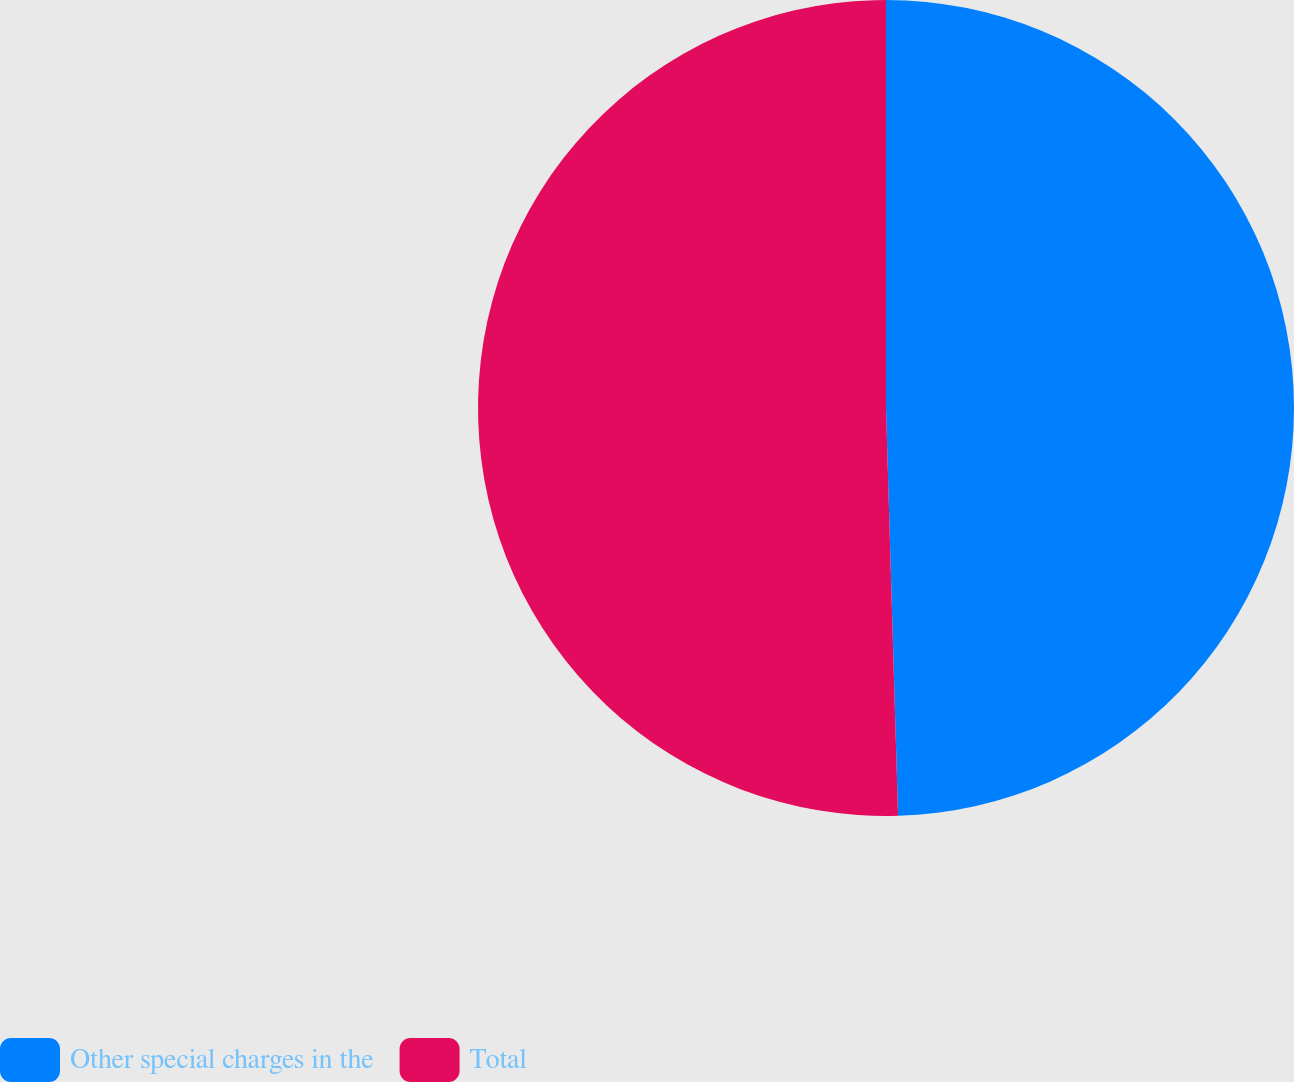Convert chart. <chart><loc_0><loc_0><loc_500><loc_500><pie_chart><fcel>Other special charges in the<fcel>Total<nl><fcel>49.53%<fcel>50.47%<nl></chart> 